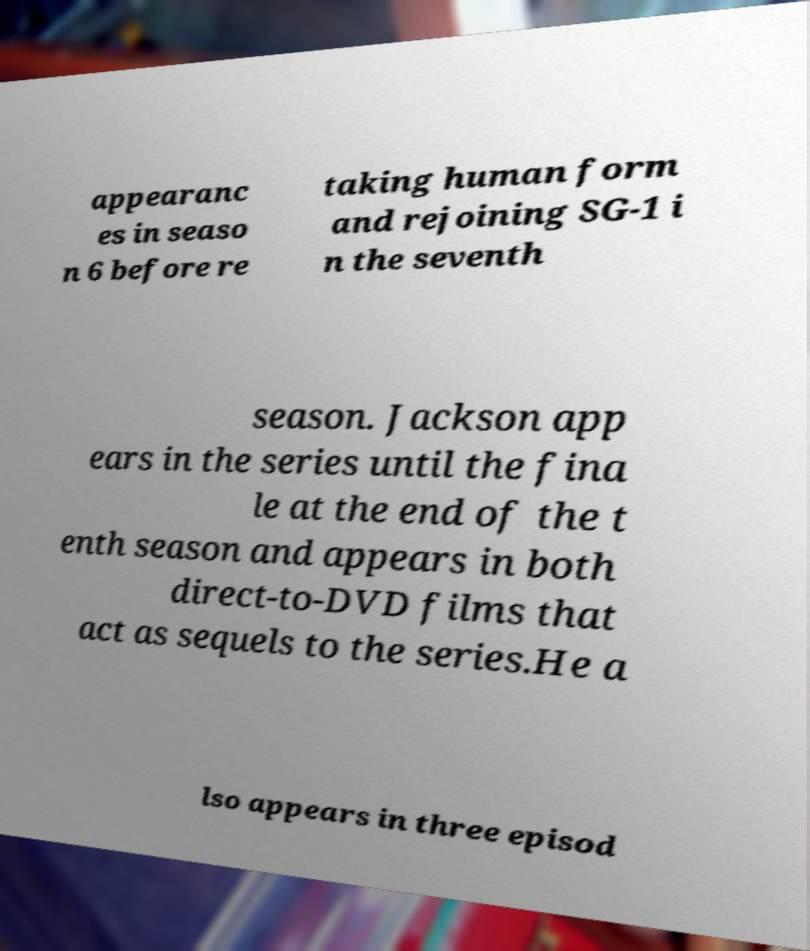Could you extract and type out the text from this image? appearanc es in seaso n 6 before re taking human form and rejoining SG-1 i n the seventh season. Jackson app ears in the series until the fina le at the end of the t enth season and appears in both direct-to-DVD films that act as sequels to the series.He a lso appears in three episod 